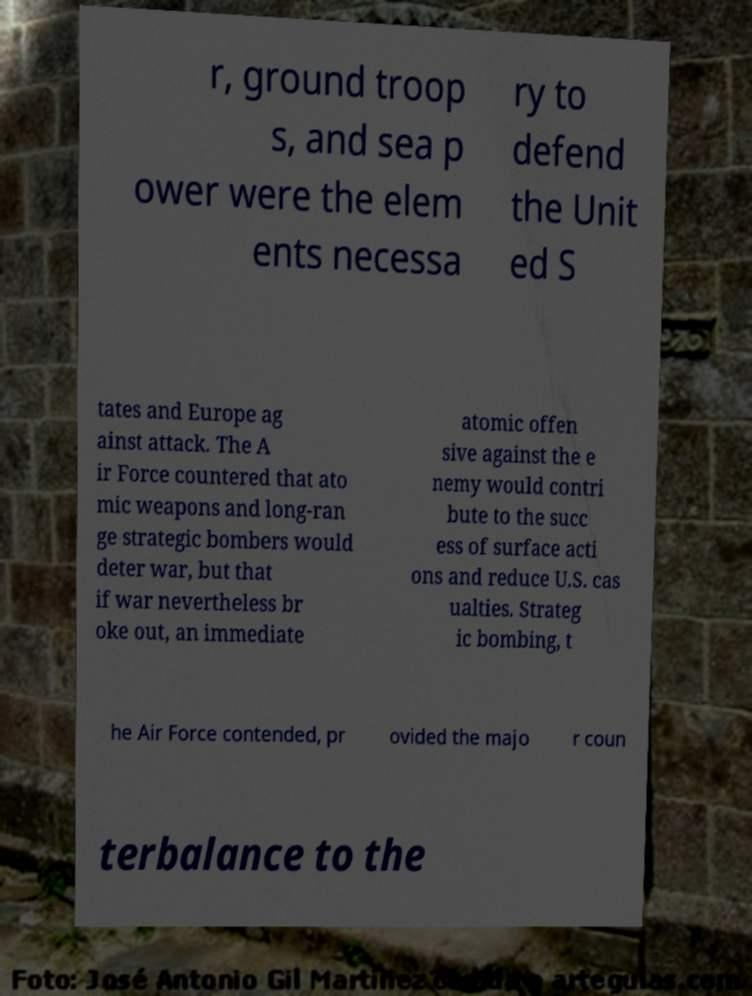Please read and relay the text visible in this image. What does it say? r, ground troop s, and sea p ower were the elem ents necessa ry to defend the Unit ed S tates and Europe ag ainst attack. The A ir Force countered that ato mic weapons and long-ran ge strategic bombers would deter war, but that if war nevertheless br oke out, an immediate atomic offen sive against the e nemy would contri bute to the succ ess of surface acti ons and reduce U.S. cas ualties. Strateg ic bombing, t he Air Force contended, pr ovided the majo r coun terbalance to the 